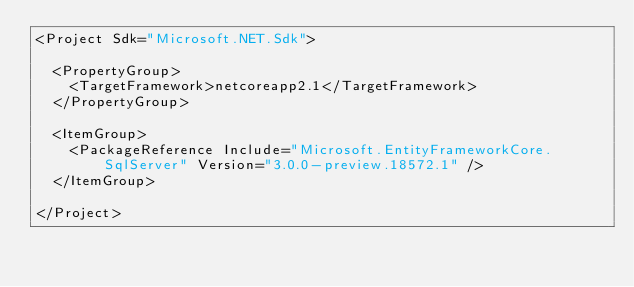<code> <loc_0><loc_0><loc_500><loc_500><_XML_><Project Sdk="Microsoft.NET.Sdk">

  <PropertyGroup>
    <TargetFramework>netcoreapp2.1</TargetFramework>
  </PropertyGroup>

  <ItemGroup>
    <PackageReference Include="Microsoft.EntityFrameworkCore.SqlServer" Version="3.0.0-preview.18572.1" />
  </ItemGroup>

</Project>
</code> 